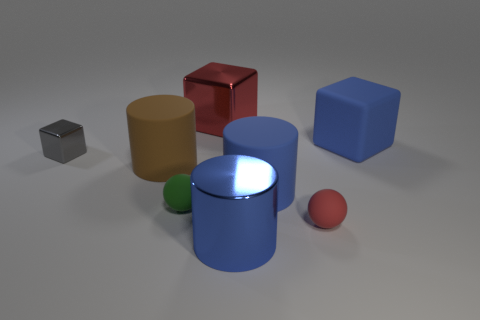Does the tiny metal block have the same color as the tiny rubber thing that is on the right side of the big red metallic object?
Provide a succinct answer. No. Are there the same number of big red metal cubes on the right side of the tiny gray metal thing and small red balls that are left of the big red metal block?
Your response must be concise. No. What number of large objects have the same shape as the tiny gray thing?
Your answer should be very brief. 2. Are there any shiny cylinders?
Keep it short and to the point. Yes. Are the red sphere and the ball that is behind the red ball made of the same material?
Your response must be concise. Yes. There is a brown object that is the same size as the blue block; what material is it?
Provide a short and direct response. Rubber. Are there any red spheres made of the same material as the green thing?
Provide a succinct answer. Yes. There is a large object in front of the big blue cylinder that is behind the green matte ball; is there a big metal cylinder that is in front of it?
Your answer should be compact. No. What is the shape of the red metallic object that is the same size as the matte cube?
Provide a short and direct response. Cube. There is a blue matte cube that is behind the big brown rubber cylinder; is it the same size as the metal block on the right side of the tiny gray cube?
Your answer should be compact. Yes. 